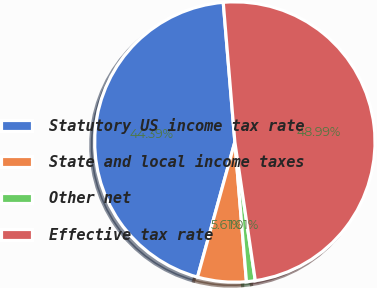Convert chart to OTSL. <chart><loc_0><loc_0><loc_500><loc_500><pie_chart><fcel>Statutory US income tax rate<fcel>State and local income taxes<fcel>Other net<fcel>Effective tax rate<nl><fcel>44.39%<fcel>5.61%<fcel>1.01%<fcel>48.99%<nl></chart> 